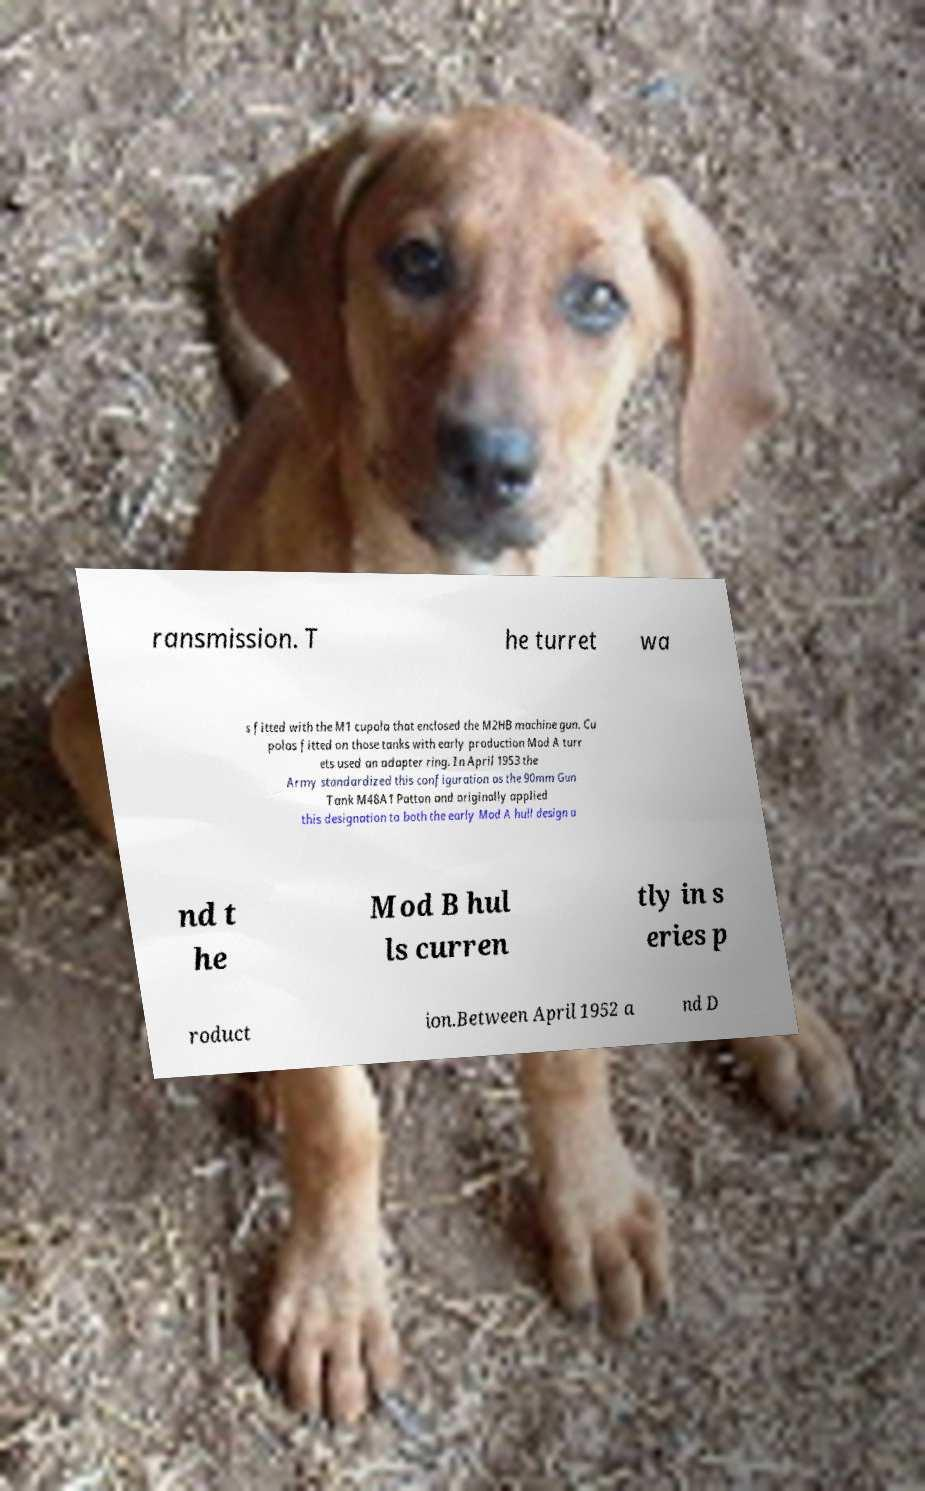Please read and relay the text visible in this image. What does it say? ransmission. T he turret wa s fitted with the M1 cupola that enclosed the M2HB machine gun. Cu polas fitted on those tanks with early production Mod A turr ets used an adapter ring. In April 1953 the Army standardized this configuration as the 90mm Gun Tank M48A1 Patton and originally applied this designation to both the early Mod A hull design a nd t he Mod B hul ls curren tly in s eries p roduct ion.Between April 1952 a nd D 